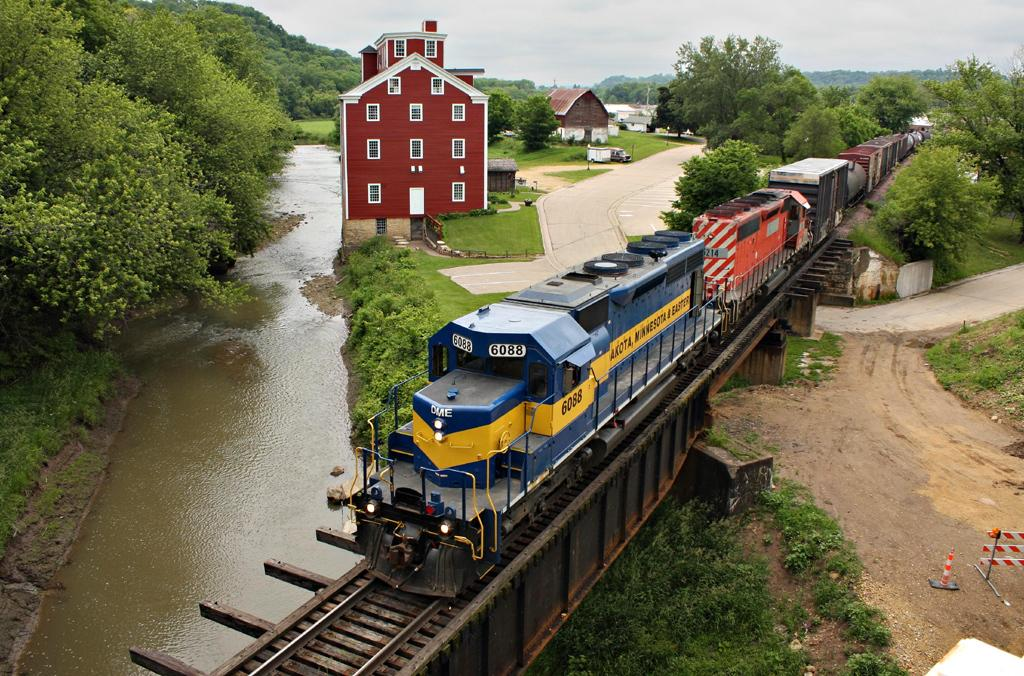What is the main subject of the image? The main subject of the image is a train. What color is the train engine? The train engine is blue. What is located at the bottom of the image? There is a track at the bottom of the image. What can be seen in the background of the image? There is a house and trees in the background of the image. How many cherries can be seen on the train in the image? There are no cherries present on the train in the image. What is the taste of the train in the image? Trains do not have a taste, as they are not edible. 